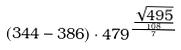<formula> <loc_0><loc_0><loc_500><loc_500>( 3 4 4 - 3 8 6 ) \cdot 4 7 9 ^ { \frac { \frac { \sqrt { 4 9 5 } } { 1 0 8 } } { 7 } }</formula> 